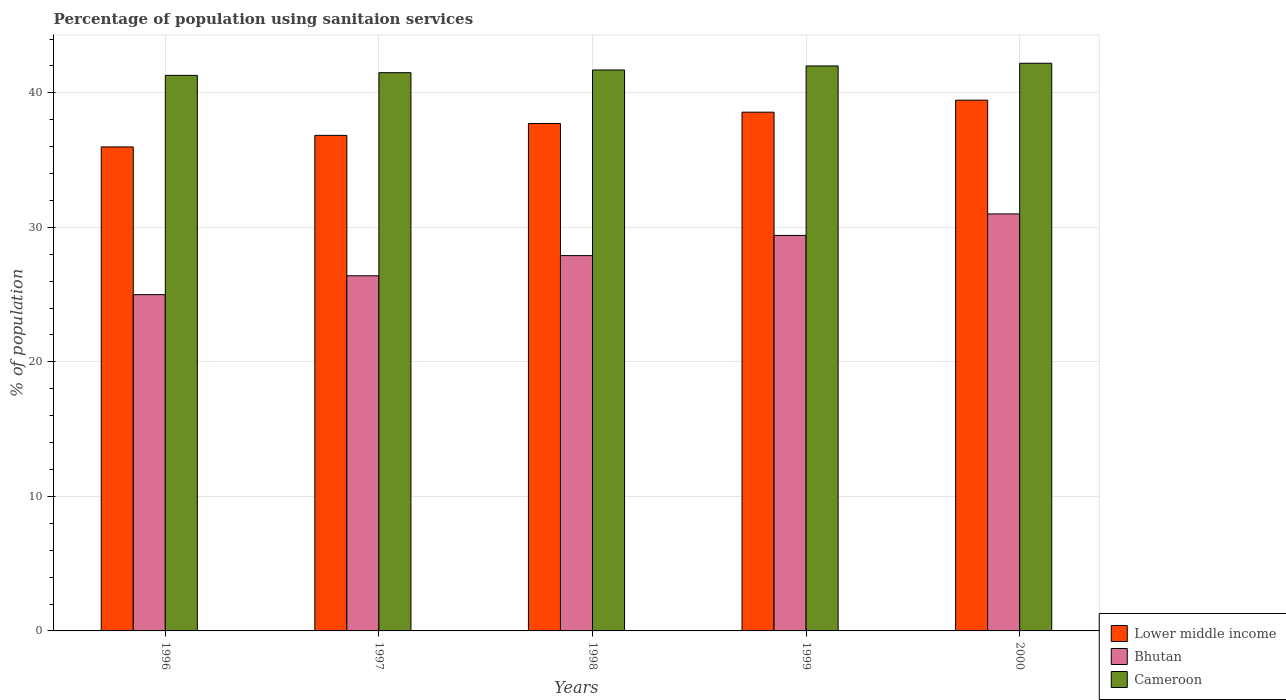How many different coloured bars are there?
Keep it short and to the point. 3. Are the number of bars per tick equal to the number of legend labels?
Keep it short and to the point. Yes. In how many cases, is the number of bars for a given year not equal to the number of legend labels?
Provide a short and direct response. 0. What is the percentage of population using sanitaion services in Bhutan in 1999?
Provide a short and direct response. 29.4. Across all years, what is the maximum percentage of population using sanitaion services in Lower middle income?
Your answer should be very brief. 39.46. Across all years, what is the minimum percentage of population using sanitaion services in Lower middle income?
Ensure brevity in your answer.  35.98. In which year was the percentage of population using sanitaion services in Cameroon maximum?
Offer a very short reply. 2000. What is the total percentage of population using sanitaion services in Bhutan in the graph?
Offer a very short reply. 139.7. What is the difference between the percentage of population using sanitaion services in Cameroon in 1997 and that in 1998?
Make the answer very short. -0.2. What is the difference between the percentage of population using sanitaion services in Cameroon in 1997 and the percentage of population using sanitaion services in Bhutan in 1999?
Provide a succinct answer. 12.1. What is the average percentage of population using sanitaion services in Lower middle income per year?
Provide a short and direct response. 37.71. In the year 1998, what is the difference between the percentage of population using sanitaion services in Lower middle income and percentage of population using sanitaion services in Bhutan?
Offer a terse response. 9.82. In how many years, is the percentage of population using sanitaion services in Lower middle income greater than 32 %?
Offer a terse response. 5. What is the ratio of the percentage of population using sanitaion services in Cameroon in 1997 to that in 1998?
Ensure brevity in your answer.  1. What is the difference between the highest and the second highest percentage of population using sanitaion services in Lower middle income?
Give a very brief answer. 0.89. What does the 3rd bar from the left in 1999 represents?
Your answer should be very brief. Cameroon. What does the 1st bar from the right in 2000 represents?
Keep it short and to the point. Cameroon. How many bars are there?
Give a very brief answer. 15. Are all the bars in the graph horizontal?
Ensure brevity in your answer.  No. How many years are there in the graph?
Your answer should be compact. 5. What is the difference between two consecutive major ticks on the Y-axis?
Your response must be concise. 10. Are the values on the major ticks of Y-axis written in scientific E-notation?
Give a very brief answer. No. How many legend labels are there?
Your answer should be compact. 3. How are the legend labels stacked?
Provide a succinct answer. Vertical. What is the title of the graph?
Your response must be concise. Percentage of population using sanitaion services. Does "OECD members" appear as one of the legend labels in the graph?
Ensure brevity in your answer.  No. What is the label or title of the Y-axis?
Give a very brief answer. % of population. What is the % of population of Lower middle income in 1996?
Provide a succinct answer. 35.98. What is the % of population in Cameroon in 1996?
Your answer should be compact. 41.3. What is the % of population in Lower middle income in 1997?
Provide a succinct answer. 36.84. What is the % of population in Bhutan in 1997?
Offer a terse response. 26.4. What is the % of population in Cameroon in 1997?
Make the answer very short. 41.5. What is the % of population of Lower middle income in 1998?
Ensure brevity in your answer.  37.72. What is the % of population of Bhutan in 1998?
Your answer should be compact. 27.9. What is the % of population of Cameroon in 1998?
Your answer should be compact. 41.7. What is the % of population in Lower middle income in 1999?
Your answer should be compact. 38.56. What is the % of population of Bhutan in 1999?
Your response must be concise. 29.4. What is the % of population in Lower middle income in 2000?
Make the answer very short. 39.46. What is the % of population in Cameroon in 2000?
Keep it short and to the point. 42.2. Across all years, what is the maximum % of population of Lower middle income?
Your answer should be very brief. 39.46. Across all years, what is the maximum % of population of Bhutan?
Provide a short and direct response. 31. Across all years, what is the maximum % of population of Cameroon?
Make the answer very short. 42.2. Across all years, what is the minimum % of population of Lower middle income?
Give a very brief answer. 35.98. Across all years, what is the minimum % of population in Bhutan?
Keep it short and to the point. 25. Across all years, what is the minimum % of population in Cameroon?
Your answer should be very brief. 41.3. What is the total % of population of Lower middle income in the graph?
Keep it short and to the point. 188.56. What is the total % of population in Bhutan in the graph?
Make the answer very short. 139.7. What is the total % of population of Cameroon in the graph?
Give a very brief answer. 208.7. What is the difference between the % of population of Lower middle income in 1996 and that in 1997?
Give a very brief answer. -0.86. What is the difference between the % of population in Lower middle income in 1996 and that in 1998?
Offer a terse response. -1.74. What is the difference between the % of population of Cameroon in 1996 and that in 1998?
Make the answer very short. -0.4. What is the difference between the % of population of Lower middle income in 1996 and that in 1999?
Your response must be concise. -2.58. What is the difference between the % of population of Cameroon in 1996 and that in 1999?
Your answer should be compact. -0.7. What is the difference between the % of population in Lower middle income in 1996 and that in 2000?
Provide a succinct answer. -3.48. What is the difference between the % of population of Cameroon in 1996 and that in 2000?
Provide a succinct answer. -0.9. What is the difference between the % of population in Lower middle income in 1997 and that in 1998?
Make the answer very short. -0.88. What is the difference between the % of population of Lower middle income in 1997 and that in 1999?
Make the answer very short. -1.72. What is the difference between the % of population of Lower middle income in 1997 and that in 2000?
Your answer should be very brief. -2.62. What is the difference between the % of population of Bhutan in 1997 and that in 2000?
Keep it short and to the point. -4.6. What is the difference between the % of population in Cameroon in 1997 and that in 2000?
Provide a short and direct response. -0.7. What is the difference between the % of population in Lower middle income in 1998 and that in 1999?
Your answer should be very brief. -0.84. What is the difference between the % of population in Lower middle income in 1998 and that in 2000?
Offer a terse response. -1.74. What is the difference between the % of population in Bhutan in 1998 and that in 2000?
Provide a succinct answer. -3.1. What is the difference between the % of population of Cameroon in 1998 and that in 2000?
Your answer should be very brief. -0.5. What is the difference between the % of population of Lower middle income in 1999 and that in 2000?
Provide a short and direct response. -0.89. What is the difference between the % of population in Bhutan in 1999 and that in 2000?
Your answer should be compact. -1.6. What is the difference between the % of population in Cameroon in 1999 and that in 2000?
Your answer should be compact. -0.2. What is the difference between the % of population in Lower middle income in 1996 and the % of population in Bhutan in 1997?
Keep it short and to the point. 9.58. What is the difference between the % of population of Lower middle income in 1996 and the % of population of Cameroon in 1997?
Ensure brevity in your answer.  -5.52. What is the difference between the % of population in Bhutan in 1996 and the % of population in Cameroon in 1997?
Give a very brief answer. -16.5. What is the difference between the % of population of Lower middle income in 1996 and the % of population of Bhutan in 1998?
Your response must be concise. 8.08. What is the difference between the % of population of Lower middle income in 1996 and the % of population of Cameroon in 1998?
Keep it short and to the point. -5.72. What is the difference between the % of population of Bhutan in 1996 and the % of population of Cameroon in 1998?
Your response must be concise. -16.7. What is the difference between the % of population in Lower middle income in 1996 and the % of population in Bhutan in 1999?
Give a very brief answer. 6.58. What is the difference between the % of population of Lower middle income in 1996 and the % of population of Cameroon in 1999?
Your answer should be very brief. -6.02. What is the difference between the % of population in Lower middle income in 1996 and the % of population in Bhutan in 2000?
Ensure brevity in your answer.  4.98. What is the difference between the % of population in Lower middle income in 1996 and the % of population in Cameroon in 2000?
Keep it short and to the point. -6.22. What is the difference between the % of population in Bhutan in 1996 and the % of population in Cameroon in 2000?
Your response must be concise. -17.2. What is the difference between the % of population in Lower middle income in 1997 and the % of population in Bhutan in 1998?
Your answer should be compact. 8.94. What is the difference between the % of population in Lower middle income in 1997 and the % of population in Cameroon in 1998?
Provide a short and direct response. -4.86. What is the difference between the % of population of Bhutan in 1997 and the % of population of Cameroon in 1998?
Your answer should be very brief. -15.3. What is the difference between the % of population of Lower middle income in 1997 and the % of population of Bhutan in 1999?
Provide a short and direct response. 7.44. What is the difference between the % of population of Lower middle income in 1997 and the % of population of Cameroon in 1999?
Offer a very short reply. -5.16. What is the difference between the % of population in Bhutan in 1997 and the % of population in Cameroon in 1999?
Your answer should be very brief. -15.6. What is the difference between the % of population of Lower middle income in 1997 and the % of population of Bhutan in 2000?
Offer a terse response. 5.84. What is the difference between the % of population in Lower middle income in 1997 and the % of population in Cameroon in 2000?
Keep it short and to the point. -5.36. What is the difference between the % of population in Bhutan in 1997 and the % of population in Cameroon in 2000?
Give a very brief answer. -15.8. What is the difference between the % of population in Lower middle income in 1998 and the % of population in Bhutan in 1999?
Give a very brief answer. 8.32. What is the difference between the % of population in Lower middle income in 1998 and the % of population in Cameroon in 1999?
Give a very brief answer. -4.28. What is the difference between the % of population in Bhutan in 1998 and the % of population in Cameroon in 1999?
Provide a succinct answer. -14.1. What is the difference between the % of population in Lower middle income in 1998 and the % of population in Bhutan in 2000?
Offer a very short reply. 6.72. What is the difference between the % of population in Lower middle income in 1998 and the % of population in Cameroon in 2000?
Your response must be concise. -4.48. What is the difference between the % of population of Bhutan in 1998 and the % of population of Cameroon in 2000?
Offer a terse response. -14.3. What is the difference between the % of population in Lower middle income in 1999 and the % of population in Bhutan in 2000?
Your response must be concise. 7.56. What is the difference between the % of population of Lower middle income in 1999 and the % of population of Cameroon in 2000?
Offer a terse response. -3.64. What is the average % of population in Lower middle income per year?
Offer a terse response. 37.71. What is the average % of population of Bhutan per year?
Your response must be concise. 27.94. What is the average % of population of Cameroon per year?
Your answer should be compact. 41.74. In the year 1996, what is the difference between the % of population of Lower middle income and % of population of Bhutan?
Your response must be concise. 10.98. In the year 1996, what is the difference between the % of population of Lower middle income and % of population of Cameroon?
Offer a terse response. -5.32. In the year 1996, what is the difference between the % of population of Bhutan and % of population of Cameroon?
Your answer should be compact. -16.3. In the year 1997, what is the difference between the % of population of Lower middle income and % of population of Bhutan?
Provide a short and direct response. 10.44. In the year 1997, what is the difference between the % of population in Lower middle income and % of population in Cameroon?
Offer a terse response. -4.66. In the year 1997, what is the difference between the % of population in Bhutan and % of population in Cameroon?
Give a very brief answer. -15.1. In the year 1998, what is the difference between the % of population of Lower middle income and % of population of Bhutan?
Your answer should be compact. 9.82. In the year 1998, what is the difference between the % of population in Lower middle income and % of population in Cameroon?
Ensure brevity in your answer.  -3.98. In the year 1998, what is the difference between the % of population of Bhutan and % of population of Cameroon?
Ensure brevity in your answer.  -13.8. In the year 1999, what is the difference between the % of population in Lower middle income and % of population in Bhutan?
Your answer should be compact. 9.16. In the year 1999, what is the difference between the % of population in Lower middle income and % of population in Cameroon?
Make the answer very short. -3.44. In the year 2000, what is the difference between the % of population in Lower middle income and % of population in Bhutan?
Your response must be concise. 8.46. In the year 2000, what is the difference between the % of population in Lower middle income and % of population in Cameroon?
Your answer should be very brief. -2.74. What is the ratio of the % of population of Lower middle income in 1996 to that in 1997?
Your answer should be very brief. 0.98. What is the ratio of the % of population of Bhutan in 1996 to that in 1997?
Your answer should be very brief. 0.95. What is the ratio of the % of population in Lower middle income in 1996 to that in 1998?
Give a very brief answer. 0.95. What is the ratio of the % of population in Bhutan in 1996 to that in 1998?
Offer a terse response. 0.9. What is the ratio of the % of population of Lower middle income in 1996 to that in 1999?
Provide a succinct answer. 0.93. What is the ratio of the % of population in Bhutan in 1996 to that in 1999?
Ensure brevity in your answer.  0.85. What is the ratio of the % of population of Cameroon in 1996 to that in 1999?
Offer a terse response. 0.98. What is the ratio of the % of population of Lower middle income in 1996 to that in 2000?
Your answer should be very brief. 0.91. What is the ratio of the % of population of Bhutan in 1996 to that in 2000?
Your response must be concise. 0.81. What is the ratio of the % of population of Cameroon in 1996 to that in 2000?
Ensure brevity in your answer.  0.98. What is the ratio of the % of population in Lower middle income in 1997 to that in 1998?
Ensure brevity in your answer.  0.98. What is the ratio of the % of population in Bhutan in 1997 to that in 1998?
Your answer should be compact. 0.95. What is the ratio of the % of population of Lower middle income in 1997 to that in 1999?
Your response must be concise. 0.96. What is the ratio of the % of population of Bhutan in 1997 to that in 1999?
Keep it short and to the point. 0.9. What is the ratio of the % of population of Lower middle income in 1997 to that in 2000?
Provide a succinct answer. 0.93. What is the ratio of the % of population in Bhutan in 1997 to that in 2000?
Keep it short and to the point. 0.85. What is the ratio of the % of population in Cameroon in 1997 to that in 2000?
Keep it short and to the point. 0.98. What is the ratio of the % of population in Lower middle income in 1998 to that in 1999?
Offer a terse response. 0.98. What is the ratio of the % of population of Bhutan in 1998 to that in 1999?
Make the answer very short. 0.95. What is the ratio of the % of population in Lower middle income in 1998 to that in 2000?
Your response must be concise. 0.96. What is the ratio of the % of population of Lower middle income in 1999 to that in 2000?
Provide a short and direct response. 0.98. What is the ratio of the % of population of Bhutan in 1999 to that in 2000?
Offer a terse response. 0.95. What is the difference between the highest and the second highest % of population of Lower middle income?
Provide a succinct answer. 0.89. What is the difference between the highest and the second highest % of population in Bhutan?
Make the answer very short. 1.6. What is the difference between the highest and the lowest % of population of Lower middle income?
Keep it short and to the point. 3.48. What is the difference between the highest and the lowest % of population of Bhutan?
Provide a short and direct response. 6. 